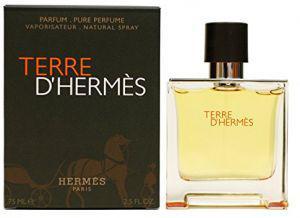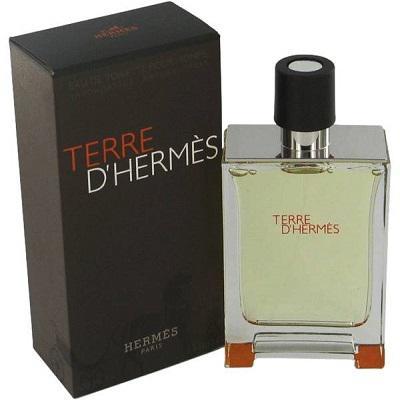The first image is the image on the left, the second image is the image on the right. Considering the images on both sides, is "All of the perfumes are in a square shaped bottle." valid? Answer yes or no. Yes. The first image is the image on the left, the second image is the image on the right. Given the left and right images, does the statement "The box in each picture is black" hold true? Answer yes or no. Yes. 